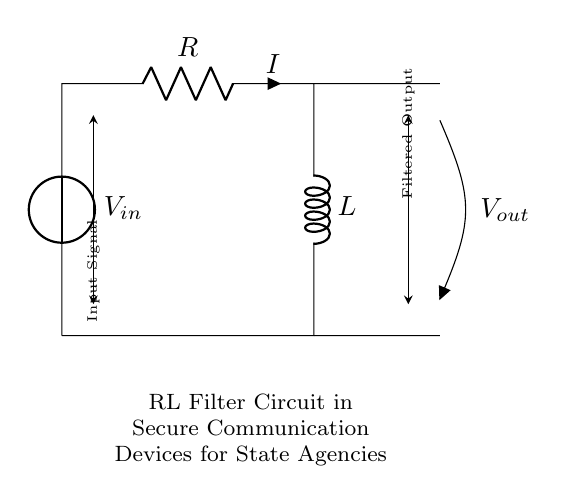What is the input voltage in this circuit? The input voltage is represented by the voltage source labeled as Vsubin, which provides the necessary potential difference for the circuit's operation.
Answer: Vsubin What components are present in the circuit? The circuit contains a voltage source, a resistor, and an inductor, which are critical for the filtering process.
Answer: Voltage source, resistor, inductor What is the role of the resistor in this circuit? The resistor limits the current flowing through the circuit and helps define the cutoff frequency in conjunction with the inductor.
Answer: Current limiting and frequency definition What is the output voltage in this circuit? The output voltage is indicated at the end of the circuit, where it is drawn as Vsubout, representing the filtered output signal from the RL circuit.
Answer: Vsubout How does the RL filter affect signal frequencies? The RL filter attenuates high-frequency signals while allowing lower frequencies to pass through, determined by the values of R and L, which affect the cutoff frequency.
Answer: Attenuates high frequencies What is the time constant in this RL circuit? The time constant, tau, is defined as the ratio of inductance (L) to resistance (R), which determines how quickly the current reaches its steady state in response to a change in voltage.
Answer: L divided by R 